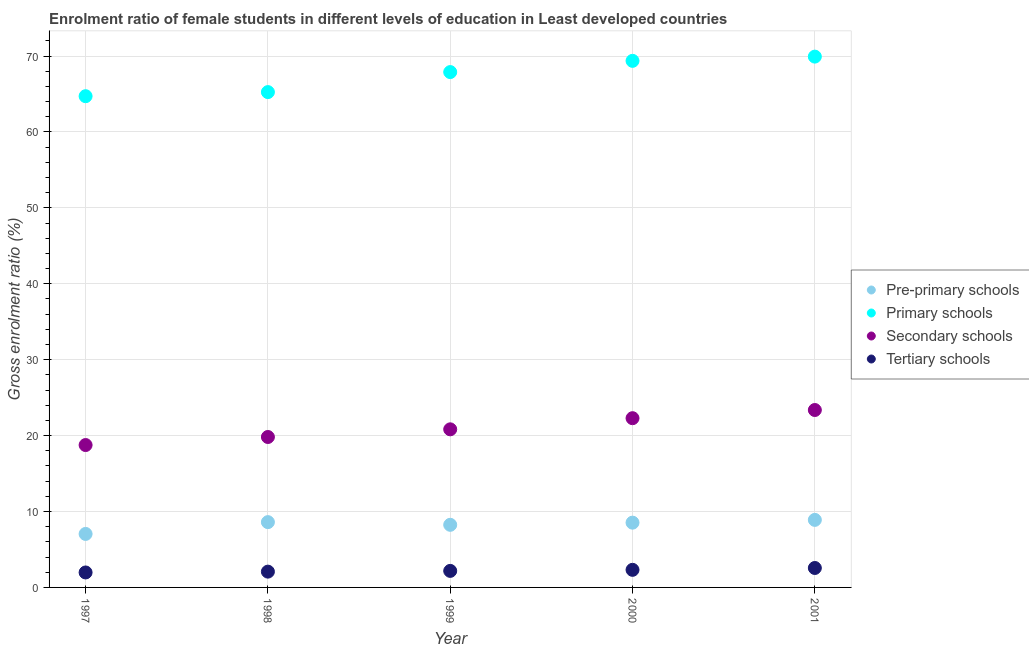How many different coloured dotlines are there?
Your answer should be very brief. 4. What is the gross enrolment ratio(male) in primary schools in 1997?
Make the answer very short. 64.71. Across all years, what is the maximum gross enrolment ratio(male) in pre-primary schools?
Provide a short and direct response. 8.9. Across all years, what is the minimum gross enrolment ratio(male) in pre-primary schools?
Your answer should be compact. 7.05. In which year was the gross enrolment ratio(male) in tertiary schools minimum?
Give a very brief answer. 1997. What is the total gross enrolment ratio(male) in secondary schools in the graph?
Provide a succinct answer. 105.06. What is the difference between the gross enrolment ratio(male) in secondary schools in 1997 and that in 2001?
Provide a short and direct response. -4.61. What is the difference between the gross enrolment ratio(male) in primary schools in 1997 and the gross enrolment ratio(male) in secondary schools in 2001?
Keep it short and to the point. 41.34. What is the average gross enrolment ratio(male) in pre-primary schools per year?
Provide a short and direct response. 8.26. In the year 1998, what is the difference between the gross enrolment ratio(male) in pre-primary schools and gross enrolment ratio(male) in primary schools?
Your response must be concise. -56.65. In how many years, is the gross enrolment ratio(male) in pre-primary schools greater than 10 %?
Offer a terse response. 0. What is the ratio of the gross enrolment ratio(male) in primary schools in 1997 to that in 2001?
Your answer should be very brief. 0.93. What is the difference between the highest and the second highest gross enrolment ratio(male) in primary schools?
Offer a terse response. 0.56. What is the difference between the highest and the lowest gross enrolment ratio(male) in secondary schools?
Your answer should be compact. 4.61. In how many years, is the gross enrolment ratio(male) in pre-primary schools greater than the average gross enrolment ratio(male) in pre-primary schools taken over all years?
Give a very brief answer. 3. Is the sum of the gross enrolment ratio(male) in secondary schools in 1997 and 2001 greater than the maximum gross enrolment ratio(male) in primary schools across all years?
Your answer should be very brief. No. Is it the case that in every year, the sum of the gross enrolment ratio(male) in tertiary schools and gross enrolment ratio(male) in primary schools is greater than the sum of gross enrolment ratio(male) in pre-primary schools and gross enrolment ratio(male) in secondary schools?
Ensure brevity in your answer.  No. Is it the case that in every year, the sum of the gross enrolment ratio(male) in pre-primary schools and gross enrolment ratio(male) in primary schools is greater than the gross enrolment ratio(male) in secondary schools?
Provide a short and direct response. Yes. Does the gross enrolment ratio(male) in pre-primary schools monotonically increase over the years?
Ensure brevity in your answer.  No. Is the gross enrolment ratio(male) in primary schools strictly greater than the gross enrolment ratio(male) in pre-primary schools over the years?
Make the answer very short. Yes. Is the gross enrolment ratio(male) in pre-primary schools strictly less than the gross enrolment ratio(male) in tertiary schools over the years?
Keep it short and to the point. No. How many dotlines are there?
Provide a short and direct response. 4. How many years are there in the graph?
Provide a succinct answer. 5. What is the difference between two consecutive major ticks on the Y-axis?
Make the answer very short. 10. Does the graph contain any zero values?
Give a very brief answer. No. Does the graph contain grids?
Keep it short and to the point. Yes. How are the legend labels stacked?
Your response must be concise. Vertical. What is the title of the graph?
Provide a succinct answer. Enrolment ratio of female students in different levels of education in Least developed countries. What is the Gross enrolment ratio (%) in Pre-primary schools in 1997?
Your answer should be compact. 7.05. What is the Gross enrolment ratio (%) in Primary schools in 1997?
Offer a very short reply. 64.71. What is the Gross enrolment ratio (%) in Secondary schools in 1997?
Make the answer very short. 18.76. What is the Gross enrolment ratio (%) in Tertiary schools in 1997?
Provide a short and direct response. 1.97. What is the Gross enrolment ratio (%) in Pre-primary schools in 1998?
Keep it short and to the point. 8.6. What is the Gross enrolment ratio (%) in Primary schools in 1998?
Provide a succinct answer. 65.25. What is the Gross enrolment ratio (%) of Secondary schools in 1998?
Your answer should be compact. 19.82. What is the Gross enrolment ratio (%) in Tertiary schools in 1998?
Keep it short and to the point. 2.08. What is the Gross enrolment ratio (%) of Pre-primary schools in 1999?
Provide a succinct answer. 8.25. What is the Gross enrolment ratio (%) of Primary schools in 1999?
Offer a very short reply. 67.88. What is the Gross enrolment ratio (%) of Secondary schools in 1999?
Keep it short and to the point. 20.83. What is the Gross enrolment ratio (%) of Tertiary schools in 1999?
Ensure brevity in your answer.  2.18. What is the Gross enrolment ratio (%) in Pre-primary schools in 2000?
Provide a succinct answer. 8.53. What is the Gross enrolment ratio (%) of Primary schools in 2000?
Your response must be concise. 69.36. What is the Gross enrolment ratio (%) of Secondary schools in 2000?
Offer a very short reply. 22.29. What is the Gross enrolment ratio (%) in Tertiary schools in 2000?
Provide a short and direct response. 2.32. What is the Gross enrolment ratio (%) in Pre-primary schools in 2001?
Your answer should be compact. 8.9. What is the Gross enrolment ratio (%) of Primary schools in 2001?
Offer a terse response. 69.92. What is the Gross enrolment ratio (%) in Secondary schools in 2001?
Your answer should be compact. 23.37. What is the Gross enrolment ratio (%) of Tertiary schools in 2001?
Provide a succinct answer. 2.56. Across all years, what is the maximum Gross enrolment ratio (%) of Pre-primary schools?
Offer a terse response. 8.9. Across all years, what is the maximum Gross enrolment ratio (%) of Primary schools?
Offer a very short reply. 69.92. Across all years, what is the maximum Gross enrolment ratio (%) in Secondary schools?
Ensure brevity in your answer.  23.37. Across all years, what is the maximum Gross enrolment ratio (%) in Tertiary schools?
Provide a short and direct response. 2.56. Across all years, what is the minimum Gross enrolment ratio (%) of Pre-primary schools?
Your answer should be very brief. 7.05. Across all years, what is the minimum Gross enrolment ratio (%) of Primary schools?
Offer a very short reply. 64.71. Across all years, what is the minimum Gross enrolment ratio (%) of Secondary schools?
Your answer should be very brief. 18.76. Across all years, what is the minimum Gross enrolment ratio (%) of Tertiary schools?
Make the answer very short. 1.97. What is the total Gross enrolment ratio (%) of Pre-primary schools in the graph?
Offer a very short reply. 41.32. What is the total Gross enrolment ratio (%) in Primary schools in the graph?
Your answer should be compact. 337.13. What is the total Gross enrolment ratio (%) of Secondary schools in the graph?
Provide a succinct answer. 105.06. What is the total Gross enrolment ratio (%) of Tertiary schools in the graph?
Offer a very short reply. 11.11. What is the difference between the Gross enrolment ratio (%) in Pre-primary schools in 1997 and that in 1998?
Keep it short and to the point. -1.55. What is the difference between the Gross enrolment ratio (%) in Primary schools in 1997 and that in 1998?
Keep it short and to the point. -0.54. What is the difference between the Gross enrolment ratio (%) in Secondary schools in 1997 and that in 1998?
Ensure brevity in your answer.  -1.06. What is the difference between the Gross enrolment ratio (%) of Tertiary schools in 1997 and that in 1998?
Provide a short and direct response. -0.11. What is the difference between the Gross enrolment ratio (%) of Pre-primary schools in 1997 and that in 1999?
Provide a succinct answer. -1.2. What is the difference between the Gross enrolment ratio (%) in Primary schools in 1997 and that in 1999?
Make the answer very short. -3.18. What is the difference between the Gross enrolment ratio (%) of Secondary schools in 1997 and that in 1999?
Keep it short and to the point. -2.07. What is the difference between the Gross enrolment ratio (%) in Tertiary schools in 1997 and that in 1999?
Offer a very short reply. -0.21. What is the difference between the Gross enrolment ratio (%) of Pre-primary schools in 1997 and that in 2000?
Keep it short and to the point. -1.48. What is the difference between the Gross enrolment ratio (%) in Primary schools in 1997 and that in 2000?
Your response must be concise. -4.65. What is the difference between the Gross enrolment ratio (%) of Secondary schools in 1997 and that in 2000?
Your answer should be very brief. -3.54. What is the difference between the Gross enrolment ratio (%) in Tertiary schools in 1997 and that in 2000?
Provide a succinct answer. -0.35. What is the difference between the Gross enrolment ratio (%) of Pre-primary schools in 1997 and that in 2001?
Your answer should be very brief. -1.85. What is the difference between the Gross enrolment ratio (%) in Primary schools in 1997 and that in 2001?
Give a very brief answer. -5.21. What is the difference between the Gross enrolment ratio (%) in Secondary schools in 1997 and that in 2001?
Your answer should be very brief. -4.61. What is the difference between the Gross enrolment ratio (%) in Tertiary schools in 1997 and that in 2001?
Ensure brevity in your answer.  -0.59. What is the difference between the Gross enrolment ratio (%) of Pre-primary schools in 1998 and that in 1999?
Provide a short and direct response. 0.35. What is the difference between the Gross enrolment ratio (%) in Primary schools in 1998 and that in 1999?
Provide a short and direct response. -2.64. What is the difference between the Gross enrolment ratio (%) of Secondary schools in 1998 and that in 1999?
Your response must be concise. -1.01. What is the difference between the Gross enrolment ratio (%) in Tertiary schools in 1998 and that in 1999?
Provide a short and direct response. -0.1. What is the difference between the Gross enrolment ratio (%) in Pre-primary schools in 1998 and that in 2000?
Make the answer very short. 0.07. What is the difference between the Gross enrolment ratio (%) of Primary schools in 1998 and that in 2000?
Make the answer very short. -4.12. What is the difference between the Gross enrolment ratio (%) of Secondary schools in 1998 and that in 2000?
Your answer should be very brief. -2.48. What is the difference between the Gross enrolment ratio (%) of Tertiary schools in 1998 and that in 2000?
Your answer should be compact. -0.24. What is the difference between the Gross enrolment ratio (%) of Pre-primary schools in 1998 and that in 2001?
Give a very brief answer. -0.3. What is the difference between the Gross enrolment ratio (%) of Primary schools in 1998 and that in 2001?
Keep it short and to the point. -4.67. What is the difference between the Gross enrolment ratio (%) of Secondary schools in 1998 and that in 2001?
Provide a succinct answer. -3.55. What is the difference between the Gross enrolment ratio (%) of Tertiary schools in 1998 and that in 2001?
Provide a succinct answer. -0.48. What is the difference between the Gross enrolment ratio (%) of Pre-primary schools in 1999 and that in 2000?
Give a very brief answer. -0.28. What is the difference between the Gross enrolment ratio (%) of Primary schools in 1999 and that in 2000?
Keep it short and to the point. -1.48. What is the difference between the Gross enrolment ratio (%) in Secondary schools in 1999 and that in 2000?
Offer a very short reply. -1.47. What is the difference between the Gross enrolment ratio (%) of Tertiary schools in 1999 and that in 2000?
Offer a terse response. -0.14. What is the difference between the Gross enrolment ratio (%) in Pre-primary schools in 1999 and that in 2001?
Make the answer very short. -0.65. What is the difference between the Gross enrolment ratio (%) in Primary schools in 1999 and that in 2001?
Provide a short and direct response. -2.04. What is the difference between the Gross enrolment ratio (%) in Secondary schools in 1999 and that in 2001?
Offer a terse response. -2.54. What is the difference between the Gross enrolment ratio (%) in Tertiary schools in 1999 and that in 2001?
Provide a succinct answer. -0.38. What is the difference between the Gross enrolment ratio (%) of Pre-primary schools in 2000 and that in 2001?
Your response must be concise. -0.37. What is the difference between the Gross enrolment ratio (%) in Primary schools in 2000 and that in 2001?
Your answer should be compact. -0.56. What is the difference between the Gross enrolment ratio (%) of Secondary schools in 2000 and that in 2001?
Offer a terse response. -1.08. What is the difference between the Gross enrolment ratio (%) in Tertiary schools in 2000 and that in 2001?
Provide a short and direct response. -0.24. What is the difference between the Gross enrolment ratio (%) of Pre-primary schools in 1997 and the Gross enrolment ratio (%) of Primary schools in 1998?
Your answer should be compact. -58.2. What is the difference between the Gross enrolment ratio (%) in Pre-primary schools in 1997 and the Gross enrolment ratio (%) in Secondary schools in 1998?
Offer a very short reply. -12.77. What is the difference between the Gross enrolment ratio (%) in Pre-primary schools in 1997 and the Gross enrolment ratio (%) in Tertiary schools in 1998?
Offer a terse response. 4.97. What is the difference between the Gross enrolment ratio (%) of Primary schools in 1997 and the Gross enrolment ratio (%) of Secondary schools in 1998?
Provide a succinct answer. 44.89. What is the difference between the Gross enrolment ratio (%) in Primary schools in 1997 and the Gross enrolment ratio (%) in Tertiary schools in 1998?
Your response must be concise. 62.63. What is the difference between the Gross enrolment ratio (%) of Secondary schools in 1997 and the Gross enrolment ratio (%) of Tertiary schools in 1998?
Offer a very short reply. 16.68. What is the difference between the Gross enrolment ratio (%) in Pre-primary schools in 1997 and the Gross enrolment ratio (%) in Primary schools in 1999?
Offer a very short reply. -60.84. What is the difference between the Gross enrolment ratio (%) in Pre-primary schools in 1997 and the Gross enrolment ratio (%) in Secondary schools in 1999?
Offer a terse response. -13.78. What is the difference between the Gross enrolment ratio (%) of Pre-primary schools in 1997 and the Gross enrolment ratio (%) of Tertiary schools in 1999?
Ensure brevity in your answer.  4.87. What is the difference between the Gross enrolment ratio (%) of Primary schools in 1997 and the Gross enrolment ratio (%) of Secondary schools in 1999?
Offer a terse response. 43.88. What is the difference between the Gross enrolment ratio (%) of Primary schools in 1997 and the Gross enrolment ratio (%) of Tertiary schools in 1999?
Offer a very short reply. 62.53. What is the difference between the Gross enrolment ratio (%) in Secondary schools in 1997 and the Gross enrolment ratio (%) in Tertiary schools in 1999?
Ensure brevity in your answer.  16.58. What is the difference between the Gross enrolment ratio (%) of Pre-primary schools in 1997 and the Gross enrolment ratio (%) of Primary schools in 2000?
Keep it short and to the point. -62.32. What is the difference between the Gross enrolment ratio (%) in Pre-primary schools in 1997 and the Gross enrolment ratio (%) in Secondary schools in 2000?
Your answer should be compact. -15.25. What is the difference between the Gross enrolment ratio (%) of Pre-primary schools in 1997 and the Gross enrolment ratio (%) of Tertiary schools in 2000?
Your answer should be compact. 4.73. What is the difference between the Gross enrolment ratio (%) in Primary schools in 1997 and the Gross enrolment ratio (%) in Secondary schools in 2000?
Keep it short and to the point. 42.42. What is the difference between the Gross enrolment ratio (%) of Primary schools in 1997 and the Gross enrolment ratio (%) of Tertiary schools in 2000?
Keep it short and to the point. 62.39. What is the difference between the Gross enrolment ratio (%) in Secondary schools in 1997 and the Gross enrolment ratio (%) in Tertiary schools in 2000?
Ensure brevity in your answer.  16.44. What is the difference between the Gross enrolment ratio (%) of Pre-primary schools in 1997 and the Gross enrolment ratio (%) of Primary schools in 2001?
Keep it short and to the point. -62.88. What is the difference between the Gross enrolment ratio (%) of Pre-primary schools in 1997 and the Gross enrolment ratio (%) of Secondary schools in 2001?
Give a very brief answer. -16.32. What is the difference between the Gross enrolment ratio (%) in Pre-primary schools in 1997 and the Gross enrolment ratio (%) in Tertiary schools in 2001?
Provide a succinct answer. 4.49. What is the difference between the Gross enrolment ratio (%) in Primary schools in 1997 and the Gross enrolment ratio (%) in Secondary schools in 2001?
Provide a short and direct response. 41.34. What is the difference between the Gross enrolment ratio (%) of Primary schools in 1997 and the Gross enrolment ratio (%) of Tertiary schools in 2001?
Give a very brief answer. 62.15. What is the difference between the Gross enrolment ratio (%) of Secondary schools in 1997 and the Gross enrolment ratio (%) of Tertiary schools in 2001?
Give a very brief answer. 16.19. What is the difference between the Gross enrolment ratio (%) of Pre-primary schools in 1998 and the Gross enrolment ratio (%) of Primary schools in 1999?
Your response must be concise. -59.28. What is the difference between the Gross enrolment ratio (%) of Pre-primary schools in 1998 and the Gross enrolment ratio (%) of Secondary schools in 1999?
Give a very brief answer. -12.23. What is the difference between the Gross enrolment ratio (%) in Pre-primary schools in 1998 and the Gross enrolment ratio (%) in Tertiary schools in 1999?
Your answer should be very brief. 6.42. What is the difference between the Gross enrolment ratio (%) in Primary schools in 1998 and the Gross enrolment ratio (%) in Secondary schools in 1999?
Make the answer very short. 44.42. What is the difference between the Gross enrolment ratio (%) in Primary schools in 1998 and the Gross enrolment ratio (%) in Tertiary schools in 1999?
Provide a succinct answer. 63.07. What is the difference between the Gross enrolment ratio (%) of Secondary schools in 1998 and the Gross enrolment ratio (%) of Tertiary schools in 1999?
Keep it short and to the point. 17.64. What is the difference between the Gross enrolment ratio (%) of Pre-primary schools in 1998 and the Gross enrolment ratio (%) of Primary schools in 2000?
Keep it short and to the point. -60.76. What is the difference between the Gross enrolment ratio (%) in Pre-primary schools in 1998 and the Gross enrolment ratio (%) in Secondary schools in 2000?
Ensure brevity in your answer.  -13.69. What is the difference between the Gross enrolment ratio (%) in Pre-primary schools in 1998 and the Gross enrolment ratio (%) in Tertiary schools in 2000?
Keep it short and to the point. 6.28. What is the difference between the Gross enrolment ratio (%) of Primary schools in 1998 and the Gross enrolment ratio (%) of Secondary schools in 2000?
Provide a succinct answer. 42.95. What is the difference between the Gross enrolment ratio (%) of Primary schools in 1998 and the Gross enrolment ratio (%) of Tertiary schools in 2000?
Make the answer very short. 62.93. What is the difference between the Gross enrolment ratio (%) of Secondary schools in 1998 and the Gross enrolment ratio (%) of Tertiary schools in 2000?
Your answer should be very brief. 17.5. What is the difference between the Gross enrolment ratio (%) in Pre-primary schools in 1998 and the Gross enrolment ratio (%) in Primary schools in 2001?
Provide a short and direct response. -61.32. What is the difference between the Gross enrolment ratio (%) of Pre-primary schools in 1998 and the Gross enrolment ratio (%) of Secondary schools in 2001?
Your answer should be compact. -14.77. What is the difference between the Gross enrolment ratio (%) in Pre-primary schools in 1998 and the Gross enrolment ratio (%) in Tertiary schools in 2001?
Your answer should be very brief. 6.04. What is the difference between the Gross enrolment ratio (%) in Primary schools in 1998 and the Gross enrolment ratio (%) in Secondary schools in 2001?
Provide a short and direct response. 41.88. What is the difference between the Gross enrolment ratio (%) of Primary schools in 1998 and the Gross enrolment ratio (%) of Tertiary schools in 2001?
Ensure brevity in your answer.  62.69. What is the difference between the Gross enrolment ratio (%) in Secondary schools in 1998 and the Gross enrolment ratio (%) in Tertiary schools in 2001?
Keep it short and to the point. 17.26. What is the difference between the Gross enrolment ratio (%) of Pre-primary schools in 1999 and the Gross enrolment ratio (%) of Primary schools in 2000?
Your answer should be compact. -61.12. What is the difference between the Gross enrolment ratio (%) in Pre-primary schools in 1999 and the Gross enrolment ratio (%) in Secondary schools in 2000?
Make the answer very short. -14.05. What is the difference between the Gross enrolment ratio (%) in Pre-primary schools in 1999 and the Gross enrolment ratio (%) in Tertiary schools in 2000?
Make the answer very short. 5.93. What is the difference between the Gross enrolment ratio (%) of Primary schools in 1999 and the Gross enrolment ratio (%) of Secondary schools in 2000?
Your answer should be compact. 45.59. What is the difference between the Gross enrolment ratio (%) in Primary schools in 1999 and the Gross enrolment ratio (%) in Tertiary schools in 2000?
Ensure brevity in your answer.  65.57. What is the difference between the Gross enrolment ratio (%) in Secondary schools in 1999 and the Gross enrolment ratio (%) in Tertiary schools in 2000?
Your response must be concise. 18.51. What is the difference between the Gross enrolment ratio (%) of Pre-primary schools in 1999 and the Gross enrolment ratio (%) of Primary schools in 2001?
Your answer should be compact. -61.67. What is the difference between the Gross enrolment ratio (%) in Pre-primary schools in 1999 and the Gross enrolment ratio (%) in Secondary schools in 2001?
Offer a very short reply. -15.12. What is the difference between the Gross enrolment ratio (%) in Pre-primary schools in 1999 and the Gross enrolment ratio (%) in Tertiary schools in 2001?
Offer a terse response. 5.69. What is the difference between the Gross enrolment ratio (%) of Primary schools in 1999 and the Gross enrolment ratio (%) of Secondary schools in 2001?
Make the answer very short. 44.51. What is the difference between the Gross enrolment ratio (%) of Primary schools in 1999 and the Gross enrolment ratio (%) of Tertiary schools in 2001?
Offer a terse response. 65.32. What is the difference between the Gross enrolment ratio (%) in Secondary schools in 1999 and the Gross enrolment ratio (%) in Tertiary schools in 2001?
Ensure brevity in your answer.  18.27. What is the difference between the Gross enrolment ratio (%) in Pre-primary schools in 2000 and the Gross enrolment ratio (%) in Primary schools in 2001?
Provide a succinct answer. -61.39. What is the difference between the Gross enrolment ratio (%) of Pre-primary schools in 2000 and the Gross enrolment ratio (%) of Secondary schools in 2001?
Your answer should be compact. -14.84. What is the difference between the Gross enrolment ratio (%) in Pre-primary schools in 2000 and the Gross enrolment ratio (%) in Tertiary schools in 2001?
Your response must be concise. 5.97. What is the difference between the Gross enrolment ratio (%) of Primary schools in 2000 and the Gross enrolment ratio (%) of Secondary schools in 2001?
Offer a very short reply. 45.99. What is the difference between the Gross enrolment ratio (%) of Primary schools in 2000 and the Gross enrolment ratio (%) of Tertiary schools in 2001?
Your answer should be compact. 66.8. What is the difference between the Gross enrolment ratio (%) of Secondary schools in 2000 and the Gross enrolment ratio (%) of Tertiary schools in 2001?
Provide a short and direct response. 19.73. What is the average Gross enrolment ratio (%) in Pre-primary schools per year?
Provide a short and direct response. 8.26. What is the average Gross enrolment ratio (%) in Primary schools per year?
Ensure brevity in your answer.  67.43. What is the average Gross enrolment ratio (%) in Secondary schools per year?
Your answer should be very brief. 21.01. What is the average Gross enrolment ratio (%) in Tertiary schools per year?
Offer a terse response. 2.22. In the year 1997, what is the difference between the Gross enrolment ratio (%) in Pre-primary schools and Gross enrolment ratio (%) in Primary schools?
Your response must be concise. -57.66. In the year 1997, what is the difference between the Gross enrolment ratio (%) in Pre-primary schools and Gross enrolment ratio (%) in Secondary schools?
Your response must be concise. -11.71. In the year 1997, what is the difference between the Gross enrolment ratio (%) in Pre-primary schools and Gross enrolment ratio (%) in Tertiary schools?
Offer a very short reply. 5.08. In the year 1997, what is the difference between the Gross enrolment ratio (%) in Primary schools and Gross enrolment ratio (%) in Secondary schools?
Offer a terse response. 45.95. In the year 1997, what is the difference between the Gross enrolment ratio (%) in Primary schools and Gross enrolment ratio (%) in Tertiary schools?
Give a very brief answer. 62.74. In the year 1997, what is the difference between the Gross enrolment ratio (%) in Secondary schools and Gross enrolment ratio (%) in Tertiary schools?
Your answer should be compact. 16.78. In the year 1998, what is the difference between the Gross enrolment ratio (%) of Pre-primary schools and Gross enrolment ratio (%) of Primary schools?
Ensure brevity in your answer.  -56.65. In the year 1998, what is the difference between the Gross enrolment ratio (%) of Pre-primary schools and Gross enrolment ratio (%) of Secondary schools?
Provide a succinct answer. -11.22. In the year 1998, what is the difference between the Gross enrolment ratio (%) in Pre-primary schools and Gross enrolment ratio (%) in Tertiary schools?
Offer a terse response. 6.52. In the year 1998, what is the difference between the Gross enrolment ratio (%) of Primary schools and Gross enrolment ratio (%) of Secondary schools?
Keep it short and to the point. 45.43. In the year 1998, what is the difference between the Gross enrolment ratio (%) of Primary schools and Gross enrolment ratio (%) of Tertiary schools?
Your answer should be compact. 63.17. In the year 1998, what is the difference between the Gross enrolment ratio (%) in Secondary schools and Gross enrolment ratio (%) in Tertiary schools?
Keep it short and to the point. 17.74. In the year 1999, what is the difference between the Gross enrolment ratio (%) in Pre-primary schools and Gross enrolment ratio (%) in Primary schools?
Your answer should be compact. -59.64. In the year 1999, what is the difference between the Gross enrolment ratio (%) in Pre-primary schools and Gross enrolment ratio (%) in Secondary schools?
Make the answer very short. -12.58. In the year 1999, what is the difference between the Gross enrolment ratio (%) in Pre-primary schools and Gross enrolment ratio (%) in Tertiary schools?
Give a very brief answer. 6.07. In the year 1999, what is the difference between the Gross enrolment ratio (%) in Primary schools and Gross enrolment ratio (%) in Secondary schools?
Make the answer very short. 47.06. In the year 1999, what is the difference between the Gross enrolment ratio (%) of Primary schools and Gross enrolment ratio (%) of Tertiary schools?
Ensure brevity in your answer.  65.71. In the year 1999, what is the difference between the Gross enrolment ratio (%) in Secondary schools and Gross enrolment ratio (%) in Tertiary schools?
Offer a very short reply. 18.65. In the year 2000, what is the difference between the Gross enrolment ratio (%) in Pre-primary schools and Gross enrolment ratio (%) in Primary schools?
Offer a very short reply. -60.83. In the year 2000, what is the difference between the Gross enrolment ratio (%) in Pre-primary schools and Gross enrolment ratio (%) in Secondary schools?
Offer a terse response. -13.76. In the year 2000, what is the difference between the Gross enrolment ratio (%) in Pre-primary schools and Gross enrolment ratio (%) in Tertiary schools?
Make the answer very short. 6.21. In the year 2000, what is the difference between the Gross enrolment ratio (%) in Primary schools and Gross enrolment ratio (%) in Secondary schools?
Your answer should be very brief. 47.07. In the year 2000, what is the difference between the Gross enrolment ratio (%) in Primary schools and Gross enrolment ratio (%) in Tertiary schools?
Make the answer very short. 67.05. In the year 2000, what is the difference between the Gross enrolment ratio (%) in Secondary schools and Gross enrolment ratio (%) in Tertiary schools?
Make the answer very short. 19.98. In the year 2001, what is the difference between the Gross enrolment ratio (%) of Pre-primary schools and Gross enrolment ratio (%) of Primary schools?
Your answer should be very brief. -61.03. In the year 2001, what is the difference between the Gross enrolment ratio (%) in Pre-primary schools and Gross enrolment ratio (%) in Secondary schools?
Make the answer very short. -14.47. In the year 2001, what is the difference between the Gross enrolment ratio (%) of Pre-primary schools and Gross enrolment ratio (%) of Tertiary schools?
Provide a succinct answer. 6.34. In the year 2001, what is the difference between the Gross enrolment ratio (%) of Primary schools and Gross enrolment ratio (%) of Secondary schools?
Your answer should be compact. 46.55. In the year 2001, what is the difference between the Gross enrolment ratio (%) in Primary schools and Gross enrolment ratio (%) in Tertiary schools?
Ensure brevity in your answer.  67.36. In the year 2001, what is the difference between the Gross enrolment ratio (%) of Secondary schools and Gross enrolment ratio (%) of Tertiary schools?
Your response must be concise. 20.81. What is the ratio of the Gross enrolment ratio (%) of Pre-primary schools in 1997 to that in 1998?
Provide a short and direct response. 0.82. What is the ratio of the Gross enrolment ratio (%) in Secondary schools in 1997 to that in 1998?
Ensure brevity in your answer.  0.95. What is the ratio of the Gross enrolment ratio (%) in Tertiary schools in 1997 to that in 1998?
Ensure brevity in your answer.  0.95. What is the ratio of the Gross enrolment ratio (%) of Pre-primary schools in 1997 to that in 1999?
Provide a succinct answer. 0.85. What is the ratio of the Gross enrolment ratio (%) in Primary schools in 1997 to that in 1999?
Give a very brief answer. 0.95. What is the ratio of the Gross enrolment ratio (%) in Secondary schools in 1997 to that in 1999?
Your answer should be compact. 0.9. What is the ratio of the Gross enrolment ratio (%) of Tertiary schools in 1997 to that in 1999?
Ensure brevity in your answer.  0.91. What is the ratio of the Gross enrolment ratio (%) of Pre-primary schools in 1997 to that in 2000?
Give a very brief answer. 0.83. What is the ratio of the Gross enrolment ratio (%) in Primary schools in 1997 to that in 2000?
Your answer should be very brief. 0.93. What is the ratio of the Gross enrolment ratio (%) in Secondary schools in 1997 to that in 2000?
Give a very brief answer. 0.84. What is the ratio of the Gross enrolment ratio (%) in Tertiary schools in 1997 to that in 2000?
Your answer should be compact. 0.85. What is the ratio of the Gross enrolment ratio (%) of Pre-primary schools in 1997 to that in 2001?
Your answer should be very brief. 0.79. What is the ratio of the Gross enrolment ratio (%) of Primary schools in 1997 to that in 2001?
Offer a terse response. 0.93. What is the ratio of the Gross enrolment ratio (%) in Secondary schools in 1997 to that in 2001?
Offer a terse response. 0.8. What is the ratio of the Gross enrolment ratio (%) of Tertiary schools in 1997 to that in 2001?
Your answer should be very brief. 0.77. What is the ratio of the Gross enrolment ratio (%) of Pre-primary schools in 1998 to that in 1999?
Keep it short and to the point. 1.04. What is the ratio of the Gross enrolment ratio (%) in Primary schools in 1998 to that in 1999?
Your response must be concise. 0.96. What is the ratio of the Gross enrolment ratio (%) of Secondary schools in 1998 to that in 1999?
Provide a short and direct response. 0.95. What is the ratio of the Gross enrolment ratio (%) of Tertiary schools in 1998 to that in 1999?
Provide a succinct answer. 0.95. What is the ratio of the Gross enrolment ratio (%) of Pre-primary schools in 1998 to that in 2000?
Make the answer very short. 1.01. What is the ratio of the Gross enrolment ratio (%) of Primary schools in 1998 to that in 2000?
Your response must be concise. 0.94. What is the ratio of the Gross enrolment ratio (%) in Secondary schools in 1998 to that in 2000?
Your answer should be very brief. 0.89. What is the ratio of the Gross enrolment ratio (%) of Tertiary schools in 1998 to that in 2000?
Ensure brevity in your answer.  0.9. What is the ratio of the Gross enrolment ratio (%) of Pre-primary schools in 1998 to that in 2001?
Keep it short and to the point. 0.97. What is the ratio of the Gross enrolment ratio (%) in Primary schools in 1998 to that in 2001?
Provide a succinct answer. 0.93. What is the ratio of the Gross enrolment ratio (%) in Secondary schools in 1998 to that in 2001?
Ensure brevity in your answer.  0.85. What is the ratio of the Gross enrolment ratio (%) of Tertiary schools in 1998 to that in 2001?
Keep it short and to the point. 0.81. What is the ratio of the Gross enrolment ratio (%) of Pre-primary schools in 1999 to that in 2000?
Give a very brief answer. 0.97. What is the ratio of the Gross enrolment ratio (%) of Primary schools in 1999 to that in 2000?
Give a very brief answer. 0.98. What is the ratio of the Gross enrolment ratio (%) in Secondary schools in 1999 to that in 2000?
Provide a short and direct response. 0.93. What is the ratio of the Gross enrolment ratio (%) of Tertiary schools in 1999 to that in 2000?
Your answer should be compact. 0.94. What is the ratio of the Gross enrolment ratio (%) in Pre-primary schools in 1999 to that in 2001?
Your answer should be very brief. 0.93. What is the ratio of the Gross enrolment ratio (%) in Primary schools in 1999 to that in 2001?
Provide a short and direct response. 0.97. What is the ratio of the Gross enrolment ratio (%) in Secondary schools in 1999 to that in 2001?
Provide a short and direct response. 0.89. What is the ratio of the Gross enrolment ratio (%) in Tertiary schools in 1999 to that in 2001?
Your answer should be very brief. 0.85. What is the ratio of the Gross enrolment ratio (%) in Pre-primary schools in 2000 to that in 2001?
Provide a succinct answer. 0.96. What is the ratio of the Gross enrolment ratio (%) of Primary schools in 2000 to that in 2001?
Give a very brief answer. 0.99. What is the ratio of the Gross enrolment ratio (%) of Secondary schools in 2000 to that in 2001?
Your answer should be very brief. 0.95. What is the ratio of the Gross enrolment ratio (%) in Tertiary schools in 2000 to that in 2001?
Provide a succinct answer. 0.9. What is the difference between the highest and the second highest Gross enrolment ratio (%) of Pre-primary schools?
Provide a succinct answer. 0.3. What is the difference between the highest and the second highest Gross enrolment ratio (%) of Primary schools?
Your answer should be very brief. 0.56. What is the difference between the highest and the second highest Gross enrolment ratio (%) of Secondary schools?
Keep it short and to the point. 1.08. What is the difference between the highest and the second highest Gross enrolment ratio (%) of Tertiary schools?
Offer a terse response. 0.24. What is the difference between the highest and the lowest Gross enrolment ratio (%) in Pre-primary schools?
Your response must be concise. 1.85. What is the difference between the highest and the lowest Gross enrolment ratio (%) in Primary schools?
Keep it short and to the point. 5.21. What is the difference between the highest and the lowest Gross enrolment ratio (%) in Secondary schools?
Ensure brevity in your answer.  4.61. What is the difference between the highest and the lowest Gross enrolment ratio (%) of Tertiary schools?
Make the answer very short. 0.59. 